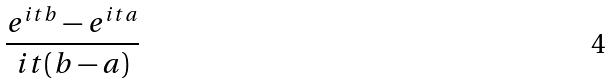Convert formula to latex. <formula><loc_0><loc_0><loc_500><loc_500>\frac { e ^ { i t b } - e ^ { i t a } } { i t ( b - a ) }</formula> 